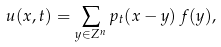Convert formula to latex. <formula><loc_0><loc_0><loc_500><loc_500>u ( x , t ) = \sum _ { y \in { Z } ^ { n } } p _ { t } ( x - y ) \, f ( y ) ,</formula> 